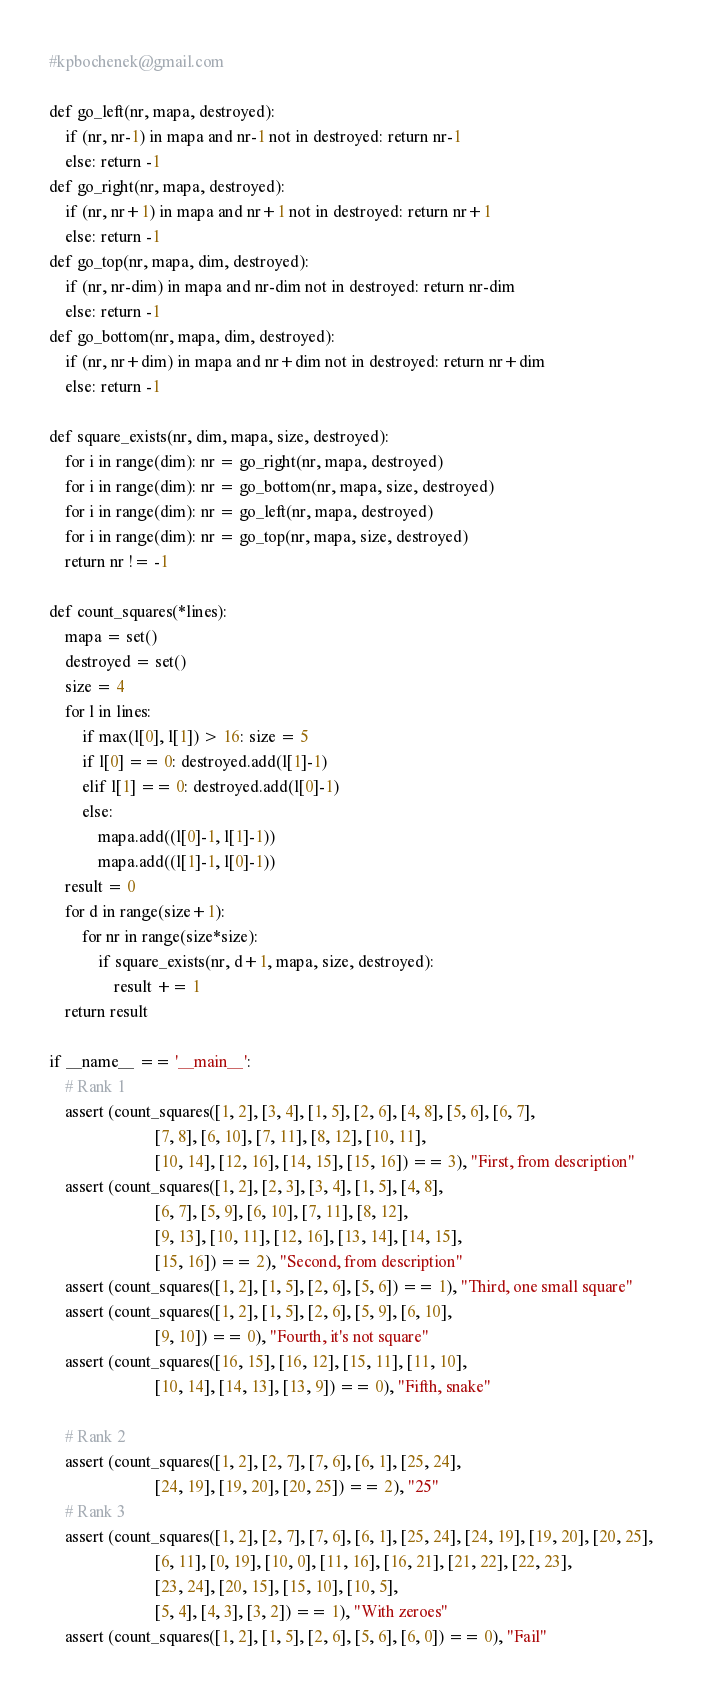Convert code to text. <code><loc_0><loc_0><loc_500><loc_500><_Python_>#kpbochenek@gmail.com

def go_left(nr, mapa, destroyed):
    if (nr, nr-1) in mapa and nr-1 not in destroyed: return nr-1
    else: return -1
def go_right(nr, mapa, destroyed):
    if (nr, nr+1) in mapa and nr+1 not in destroyed: return nr+1
    else: return -1
def go_top(nr, mapa, dim, destroyed):
    if (nr, nr-dim) in mapa and nr-dim not in destroyed: return nr-dim
    else: return -1
def go_bottom(nr, mapa, dim, destroyed):
    if (nr, nr+dim) in mapa and nr+dim not in destroyed: return nr+dim
    else: return -1

def square_exists(nr, dim, mapa, size, destroyed):
    for i in range(dim): nr = go_right(nr, mapa, destroyed)
    for i in range(dim): nr = go_bottom(nr, mapa, size, destroyed)
    for i in range(dim): nr = go_left(nr, mapa, destroyed)
    for i in range(dim): nr = go_top(nr, mapa, size, destroyed)
    return nr != -1

def count_squares(*lines):
    mapa = set()
    destroyed = set()
    size = 4
    for l in lines:
        if max(l[0], l[1]) > 16: size = 5
        if l[0] == 0: destroyed.add(l[1]-1)
        elif l[1] == 0: destroyed.add(l[0]-1)
        else:
            mapa.add((l[0]-1, l[1]-1))
            mapa.add((l[1]-1, l[0]-1))
    result = 0
    for d in range(size+1):
        for nr in range(size*size):
            if square_exists(nr, d+1, mapa, size, destroyed):
                result += 1
    return result

if __name__ == '__main__':
    # Rank 1
    assert (count_squares([1, 2], [3, 4], [1, 5], [2, 6], [4, 8], [5, 6], [6, 7],
                          [7, 8], [6, 10], [7, 11], [8, 12], [10, 11],
                          [10, 14], [12, 16], [14, 15], [15, 16]) == 3), "First, from description"
    assert (count_squares([1, 2], [2, 3], [3, 4], [1, 5], [4, 8],
                          [6, 7], [5, 9], [6, 10], [7, 11], [8, 12],
                          [9, 13], [10, 11], [12, 16], [13, 14], [14, 15],
                          [15, 16]) == 2), "Second, from description"
    assert (count_squares([1, 2], [1, 5], [2, 6], [5, 6]) == 1), "Third, one small square"
    assert (count_squares([1, 2], [1, 5], [2, 6], [5, 9], [6, 10],
                          [9, 10]) == 0), "Fourth, it's not square"
    assert (count_squares([16, 15], [16, 12], [15, 11], [11, 10],
                          [10, 14], [14, 13], [13, 9]) == 0), "Fifth, snake"

    # Rank 2
    assert (count_squares([1, 2], [2, 7], [7, 6], [6, 1], [25, 24],
                          [24, 19], [19, 20], [20, 25]) == 2), "25"
    # Rank 3
    assert (count_squares([1, 2], [2, 7], [7, 6], [6, 1], [25, 24], [24, 19], [19, 20], [20, 25],
                          [6, 11], [0, 19], [10, 0], [11, 16], [16, 21], [21, 22], [22, 23],
                          [23, 24], [20, 15], [15, 10], [10, 5],
                          [5, 4], [4, 3], [3, 2]) == 1), "With zeroes"
    assert (count_squares([1, 2], [1, 5], [2, 6], [5, 6], [6, 0]) == 0), "Fail"
</code> 